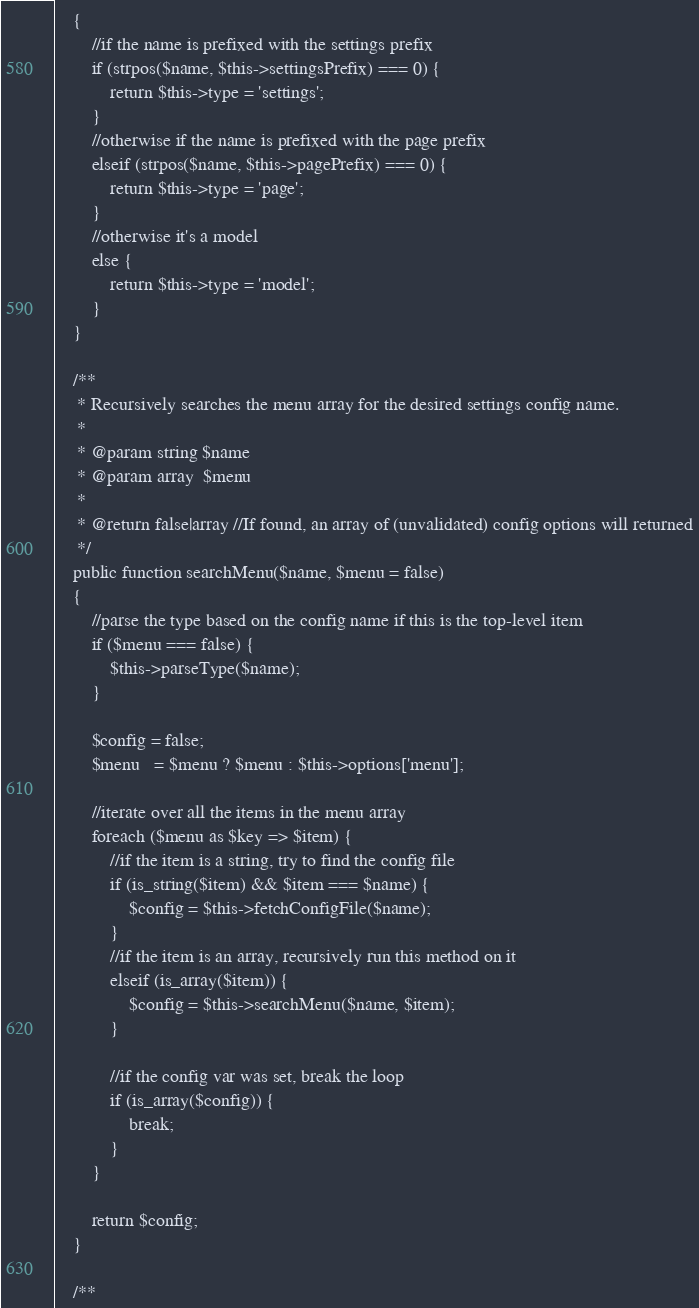Convert code to text. <code><loc_0><loc_0><loc_500><loc_500><_PHP_>    {
        //if the name is prefixed with the settings prefix
        if (strpos($name, $this->settingsPrefix) === 0) {
            return $this->type = 'settings';
        }
        //otherwise if the name is prefixed with the page prefix
        elseif (strpos($name, $this->pagePrefix) === 0) {
            return $this->type = 'page';
        }
        //otherwise it's a model
        else {
            return $this->type = 'model';
        }
    }

    /**
     * Recursively searches the menu array for the desired settings config name.
     *
     * @param string $name
     * @param array  $menu
     *
     * @return false|array //If found, an array of (unvalidated) config options will returned
     */
    public function searchMenu($name, $menu = false)
    {
        //parse the type based on the config name if this is the top-level item
        if ($menu === false) {
            $this->parseType($name);
        }

        $config = false;
        $menu   = $menu ? $menu : $this->options['menu'];

        //iterate over all the items in the menu array
        foreach ($menu as $key => $item) {
            //if the item is a string, try to find the config file
            if (is_string($item) && $item === $name) {
                $config = $this->fetchConfigFile($name);
            }
            //if the item is an array, recursively run this method on it
            elseif (is_array($item)) {
                $config = $this->searchMenu($name, $item);
            }

            //if the config var was set, break the loop
            if (is_array($config)) {
                break;
            }
        }

        return $config;
    }

    /**</code> 